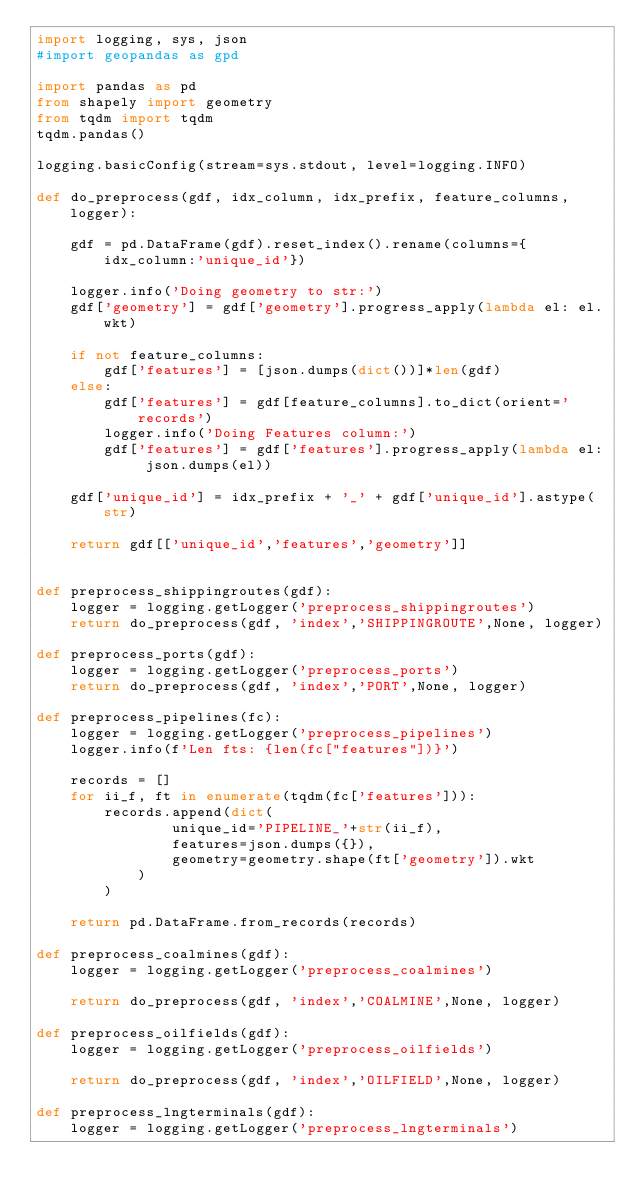<code> <loc_0><loc_0><loc_500><loc_500><_Python_>import logging, sys, json
#import geopandas as gpd

import pandas as pd
from shapely import geometry
from tqdm import tqdm
tqdm.pandas()

logging.basicConfig(stream=sys.stdout, level=logging.INFO)

def do_preprocess(gdf, idx_column, idx_prefix, feature_columns, logger):
    
    gdf = pd.DataFrame(gdf).reset_index().rename(columns={idx_column:'unique_id'})
    
    logger.info('Doing geometry to str:')
    gdf['geometry'] = gdf['geometry'].progress_apply(lambda el: el.wkt)
    
    if not feature_columns:
        gdf['features'] = [json.dumps(dict())]*len(gdf)
    else:
        gdf['features'] = gdf[feature_columns].to_dict(orient='records')
        logger.info('Doing Features column:')
        gdf['features'] = gdf['features'].progress_apply(lambda el: json.dumps(el))
    
    gdf['unique_id'] = idx_prefix + '_' + gdf['unique_id'].astype(str)
    
    return gdf[['unique_id','features','geometry']]
    

def preprocess_shippingroutes(gdf):
    logger = logging.getLogger('preprocess_shippingroutes')
    return do_preprocess(gdf, 'index','SHIPPINGROUTE',None, logger)

def preprocess_ports(gdf):
    logger = logging.getLogger('preprocess_ports')
    return do_preprocess(gdf, 'index','PORT',None, logger)

def preprocess_pipelines(fc):
    logger = logging.getLogger('preprocess_pipelines')
    logger.info(f'Len fts: {len(fc["features"])}')
    
    records = []
    for ii_f, ft in enumerate(tqdm(fc['features'])):
        records.append(dict(
                unique_id='PIPELINE_'+str(ii_f),
                features=json.dumps({}),
                geometry=geometry.shape(ft['geometry']).wkt
            )
        )    
    
    return pd.DataFrame.from_records(records)

def preprocess_coalmines(gdf):
    logger = logging.getLogger('preprocess_coalmines')

    return do_preprocess(gdf, 'index','COALMINE',None, logger)

def preprocess_oilfields(gdf):
    logger = logging.getLogger('preprocess_oilfields')

    return do_preprocess(gdf, 'index','OILFIELD',None, logger)

def preprocess_lngterminals(gdf):
    logger = logging.getLogger('preprocess_lngterminals')
</code> 